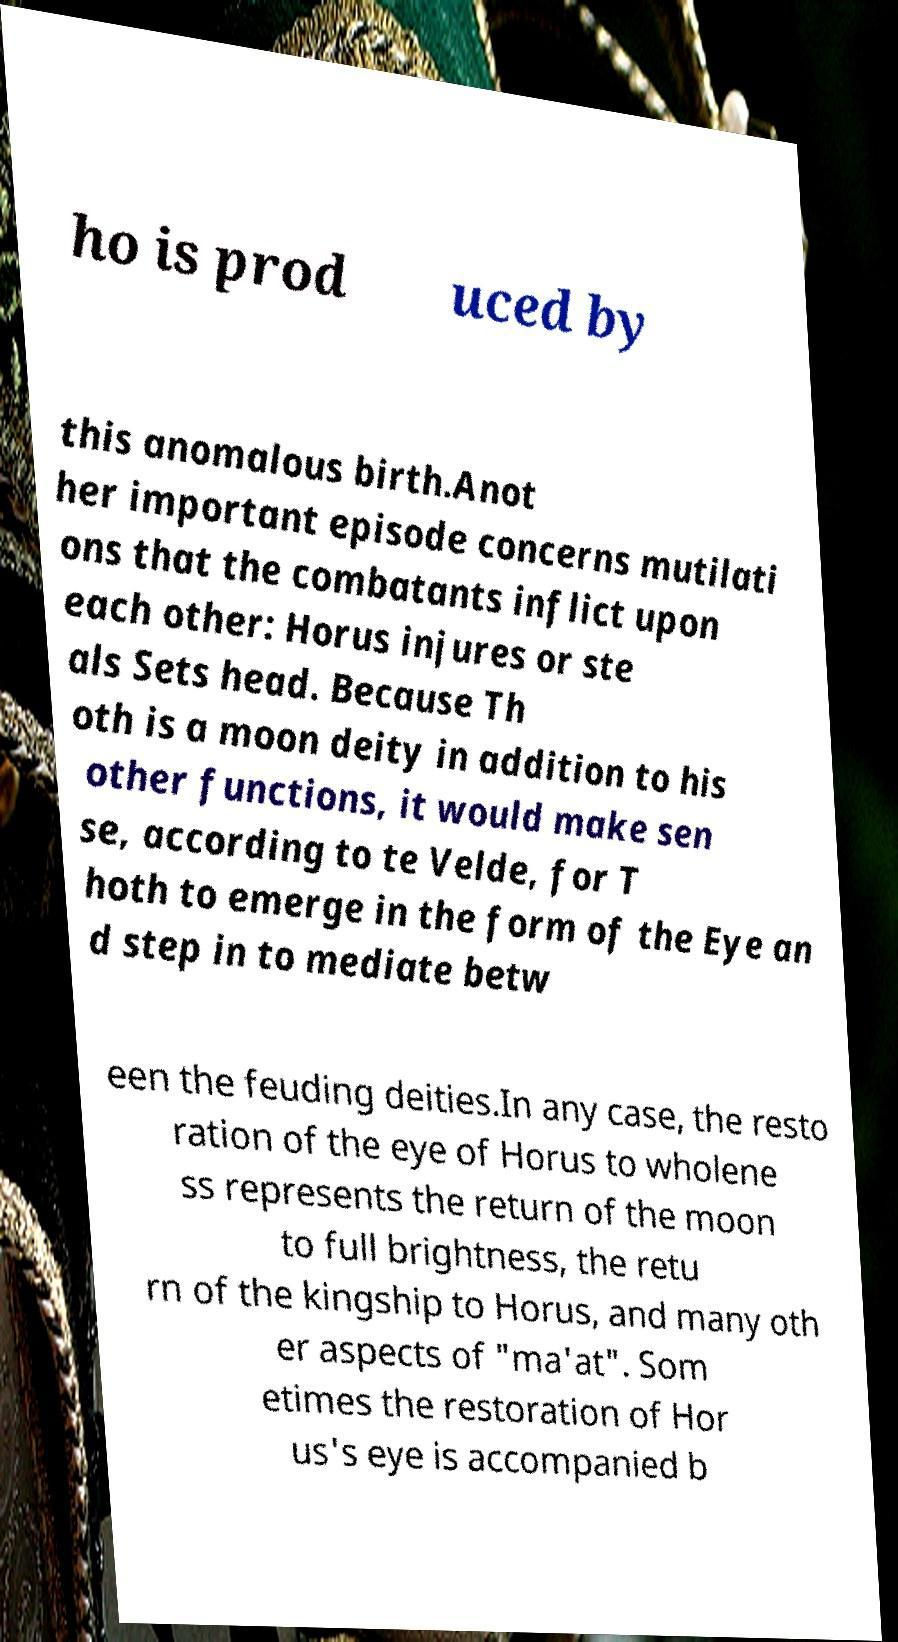Please read and relay the text visible in this image. What does it say? ho is prod uced by this anomalous birth.Anot her important episode concerns mutilati ons that the combatants inflict upon each other: Horus injures or ste als Sets head. Because Th oth is a moon deity in addition to his other functions, it would make sen se, according to te Velde, for T hoth to emerge in the form of the Eye an d step in to mediate betw een the feuding deities.In any case, the resto ration of the eye of Horus to wholene ss represents the return of the moon to full brightness, the retu rn of the kingship to Horus, and many oth er aspects of "ma'at". Som etimes the restoration of Hor us's eye is accompanied b 